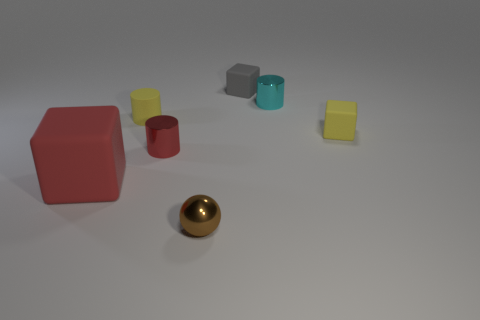Add 1 green rubber balls. How many objects exist? 8 Subtract all cylinders. How many objects are left? 4 Subtract all purple metallic cylinders. Subtract all tiny yellow cylinders. How many objects are left? 6 Add 5 tiny metal objects. How many tiny metal objects are left? 8 Add 3 yellow rubber cylinders. How many yellow rubber cylinders exist? 4 Subtract 0 cyan spheres. How many objects are left? 7 